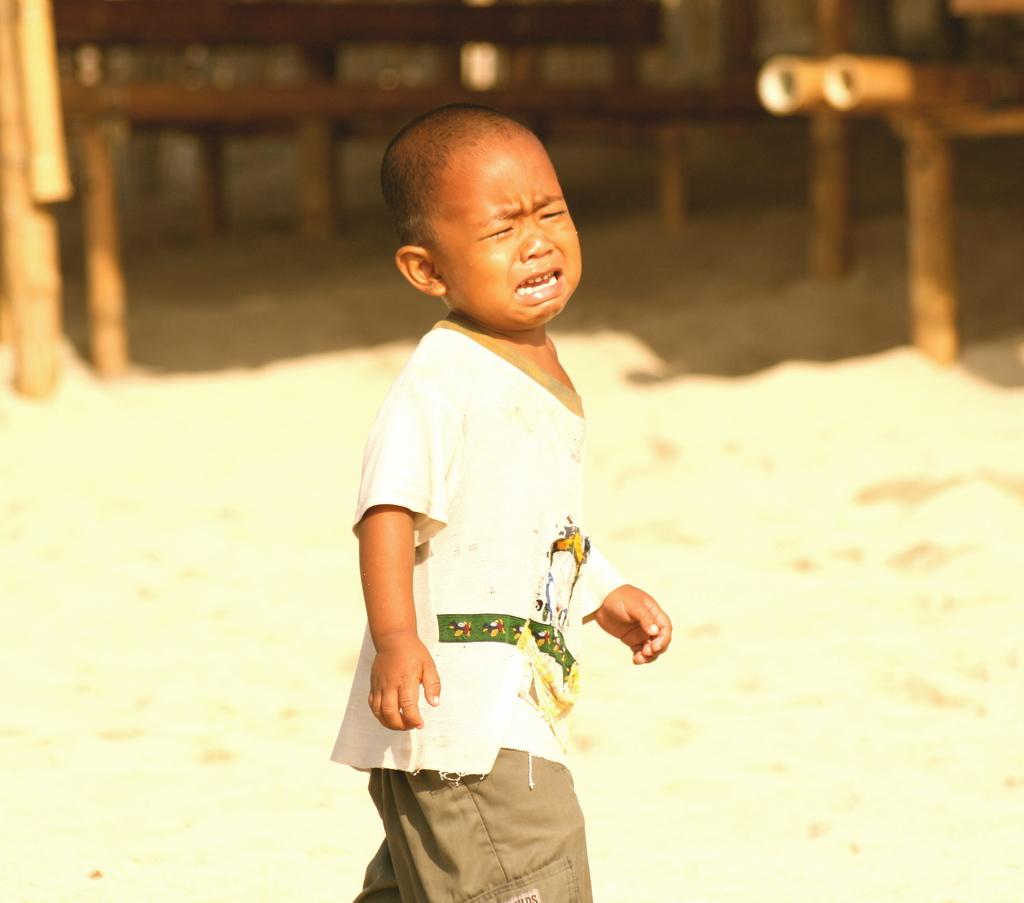What is the main subject of the picture? The main subject of the picture is a boy. What is the boy doing in the picture? The boy is crying in the picture. Can you describe the background of the image? The background of the image is blurred. What type of degree does the stranger offer the boy in the image? There is no stranger present in the image, and therefore no such interaction can be observed. What type of soda is the boy holding in the image? There is no soda present in the image; the boy is crying and no other objects are mentioned. 